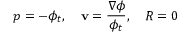<formula> <loc_0><loc_0><loc_500><loc_500>p = - \phi _ { t } , \quad v = \frac { \nabla \phi } { \phi _ { t } } , \quad R = 0</formula> 